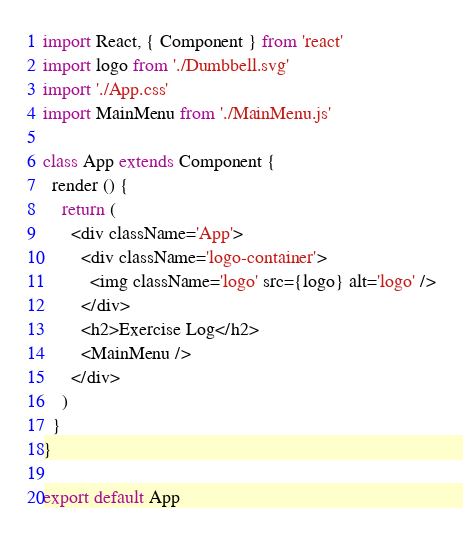<code> <loc_0><loc_0><loc_500><loc_500><_JavaScript_>import React, { Component } from 'react'
import logo from './Dumbbell.svg'
import './App.css'
import MainMenu from './MainMenu.js'

class App extends Component {
  render () {
    return (
      <div className='App'>
        <div className='logo-container'>
          <img className='logo' src={logo} alt='logo' />
        </div>
        <h2>Exercise Log</h2>
        <MainMenu />
      </div>
    )
  }
}

export default App
</code> 